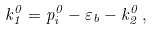Convert formula to latex. <formula><loc_0><loc_0><loc_500><loc_500>k _ { 1 } ^ { 0 } = p _ { i } ^ { 0 } - \varepsilon _ { b } - k _ { 2 } ^ { 0 } \, ,</formula> 